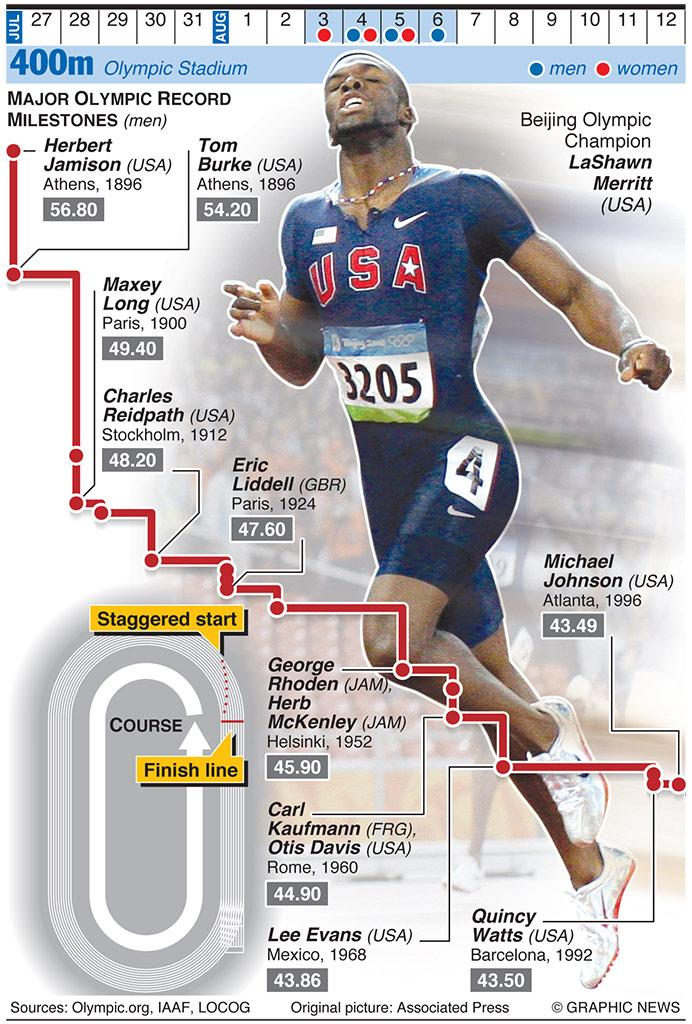Identify some key points in this picture. The chest number of the athlete depicted in the infographic is 3205. The United States' Michael Johnson set a record of 43.49 in the 400m race in 1996, cementing his status as a top athlete in the world. The image of a US athlete is featured in the infographic, and it is LaShawn Merritt. George Rhoden set a new record in the 400m race with a time of 45.90. Herbert Jamison, an athlete from the United States, set a record of 56.80 in the 400m race at the first Olympic games, making him the fastest runner in the history of the event. 